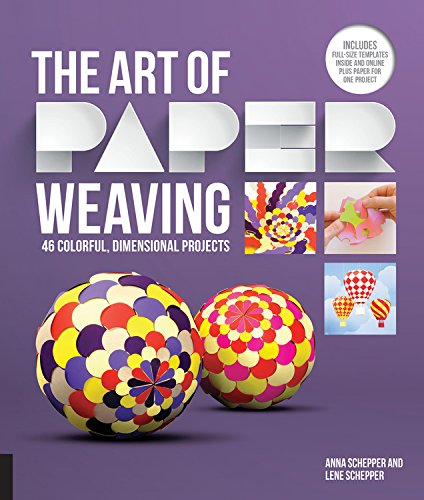What skills can someone learn from this book? From 'The Art of Paper Weaving,' readers can learn skills such as precise cutting, pattern making, color theory, and the intricacies of weaving techniques to create volume and fascinating visual textures with paper. Is this book suitable for beginners? Absolutely, this book is designed to accommodate both beginners and experienced crafters. It includes detailed step-by-step instructions and full-size templates which make it easier for newcomers to start their journey in paper weaving. 